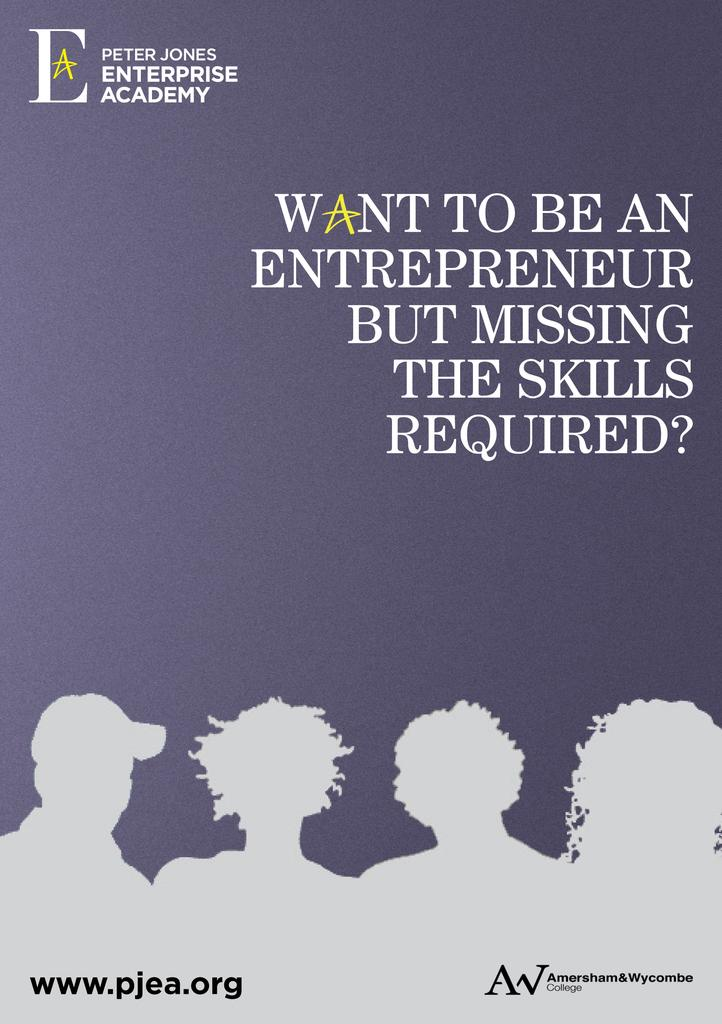<image>
Offer a succinct explanation of the picture presented. An advertisement for the Peter Jones Enterprise Academy. 